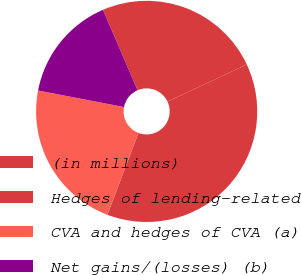Convert chart to OTSL. <chart><loc_0><loc_0><loc_500><loc_500><pie_chart><fcel>(in millions)<fcel>Hedges of lending-related<fcel>CVA and hedges of CVA (a)<fcel>Net gains/(losses) (b)<nl><fcel>24.48%<fcel>37.76%<fcel>22.25%<fcel>15.51%<nl></chart> 